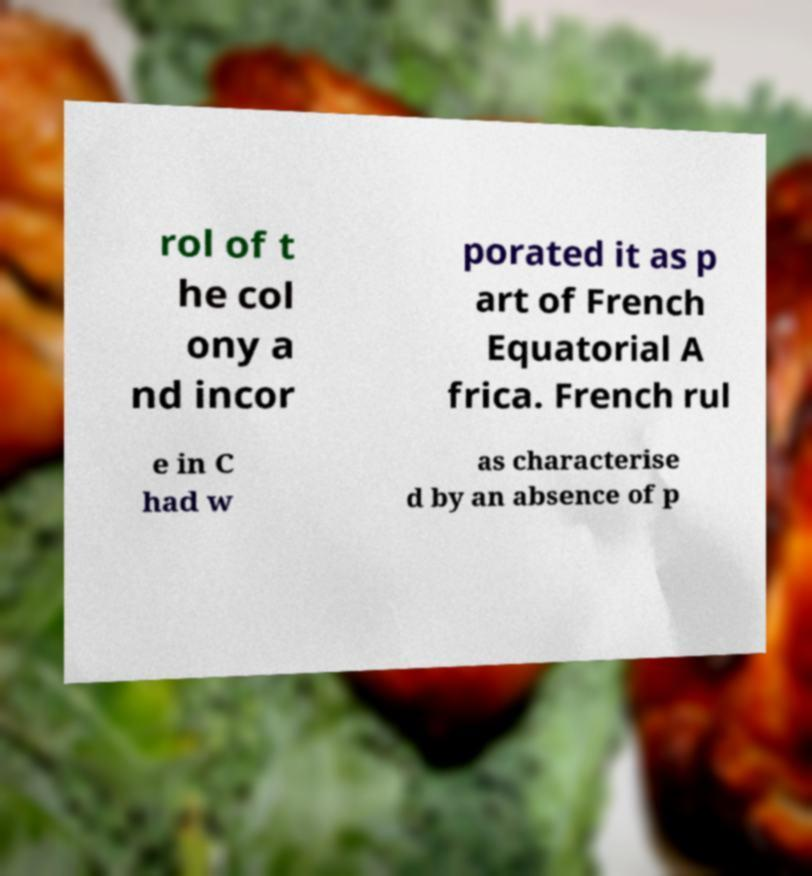Could you assist in decoding the text presented in this image and type it out clearly? rol of t he col ony a nd incor porated it as p art of French Equatorial A frica. French rul e in C had w as characterise d by an absence of p 